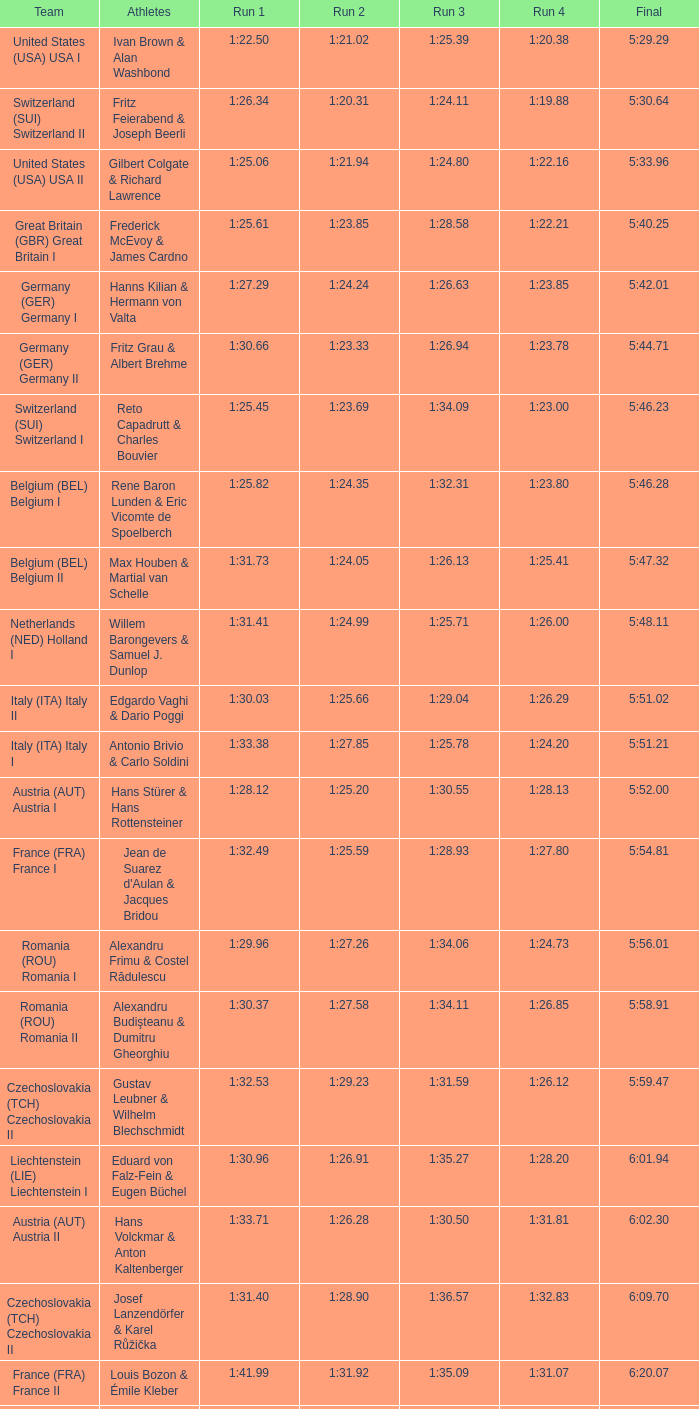Which Run 4 has a Run 3 of 1:26.63? 1:23.85. 